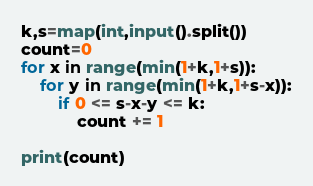Convert code to text. <code><loc_0><loc_0><loc_500><loc_500><_Python_>k,s=map(int,input().split())
count=0
for x in range(min(1+k,1+s)):
    for y in range(min(1+k,1+s-x)):
        if 0 <= s-x-y <= k:
            count += 1

print(count)
</code> 